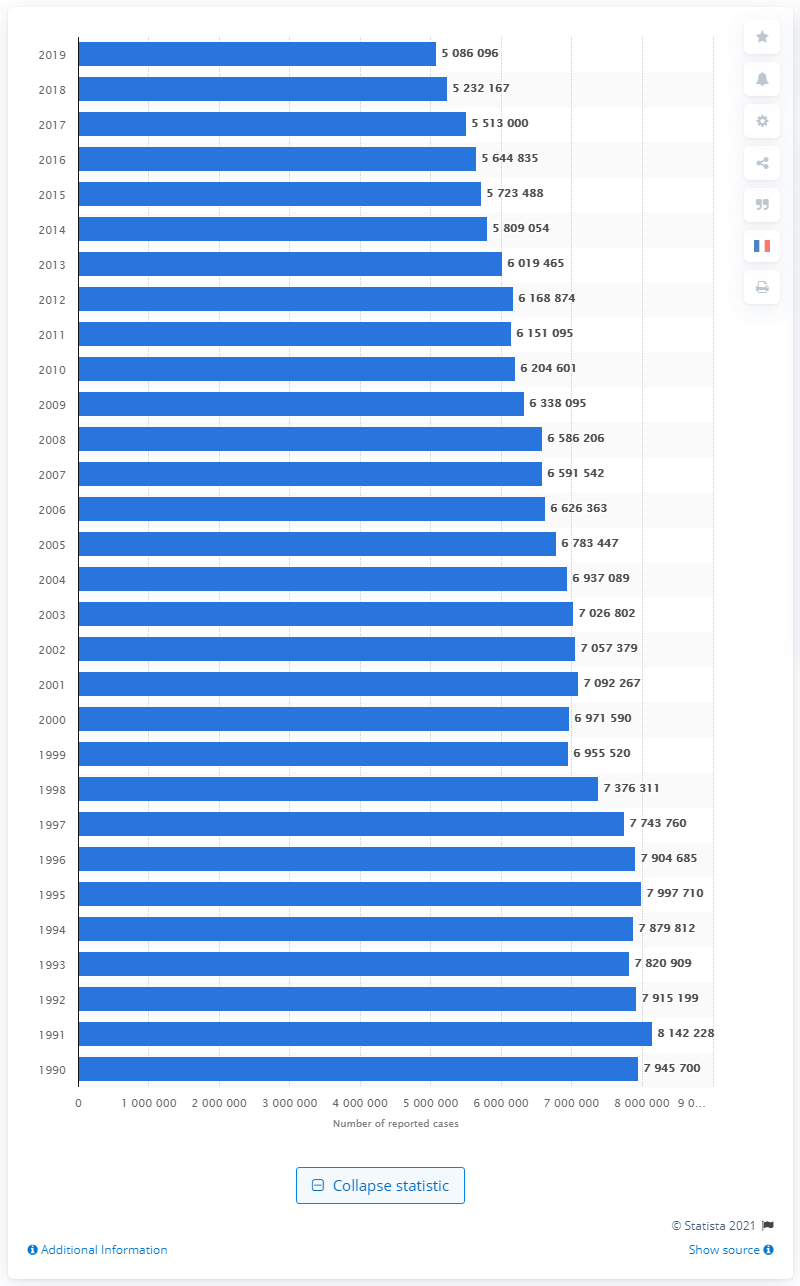Point out several critical features in this image. In 2019, there were 508,609 reported cases of larceny in the United States. 